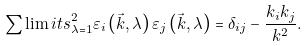Convert formula to latex. <formula><loc_0><loc_0><loc_500><loc_500>\sum \lim i t s _ { \lambda = 1 } ^ { 2 } { \varepsilon _ { i } \left ( { \vec { k } , \lambda } \right ) \varepsilon _ { j } \left ( { \vec { k } , \lambda } \right ) = \delta _ { i j } - \frac { k _ { i } k _ { j } } { k ^ { 2 } } } .</formula> 